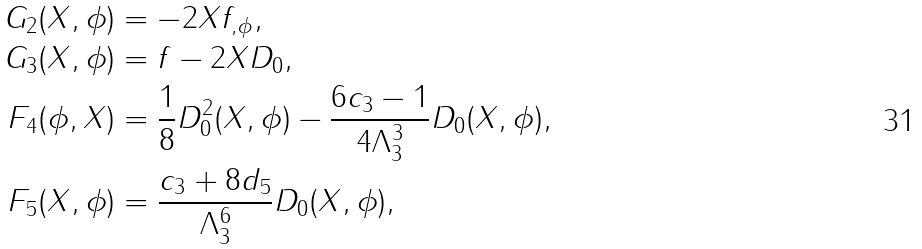<formula> <loc_0><loc_0><loc_500><loc_500>G _ { 2 } ( X , \phi ) & = - 2 X f _ { , \phi } , \\ G _ { 3 } ( X , \phi ) & = f - 2 X D _ { 0 } , \\ F _ { 4 } ( \phi , X ) & = \frac { 1 } { 8 } D _ { 0 } ^ { 2 } ( X , \phi ) - \frac { 6 c _ { 3 } - 1 } { 4 \Lambda _ { 3 } ^ { 3 } } D _ { 0 } ( X , \phi ) , \\ F _ { 5 } ( X , \phi ) & = \frac { c _ { 3 } + 8 d _ { 5 } } { \Lambda _ { 3 } ^ { 6 } } D _ { 0 } ( X , \phi ) ,</formula> 